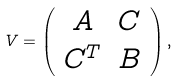Convert formula to latex. <formula><loc_0><loc_0><loc_500><loc_500>V = \left ( \begin{array} { c c } A & C \\ C ^ { T } & B \end{array} \right ) ,</formula> 